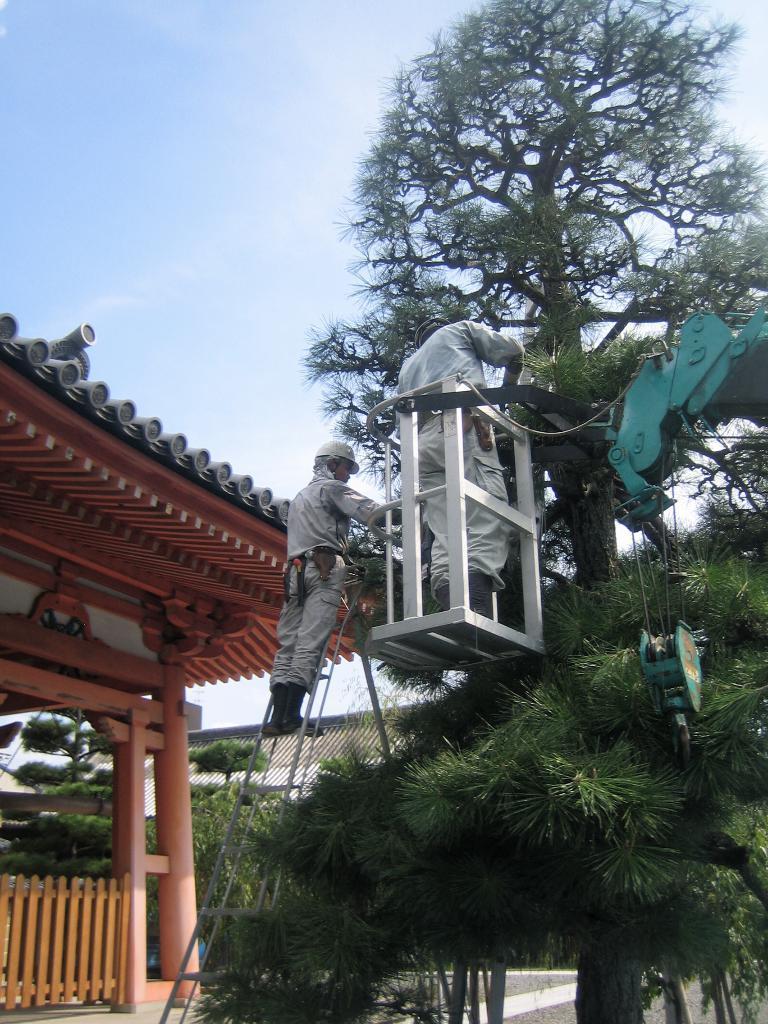Can you describe this image briefly? In the center of the image we can see two people wearing uniform. One person is standing in a metal cage attached to a crane arm. One person is wearing a helmet and standing on the ladder placed on the ground. In the background, we can see a building with a fence, group of poles, group of trees and the sky. 